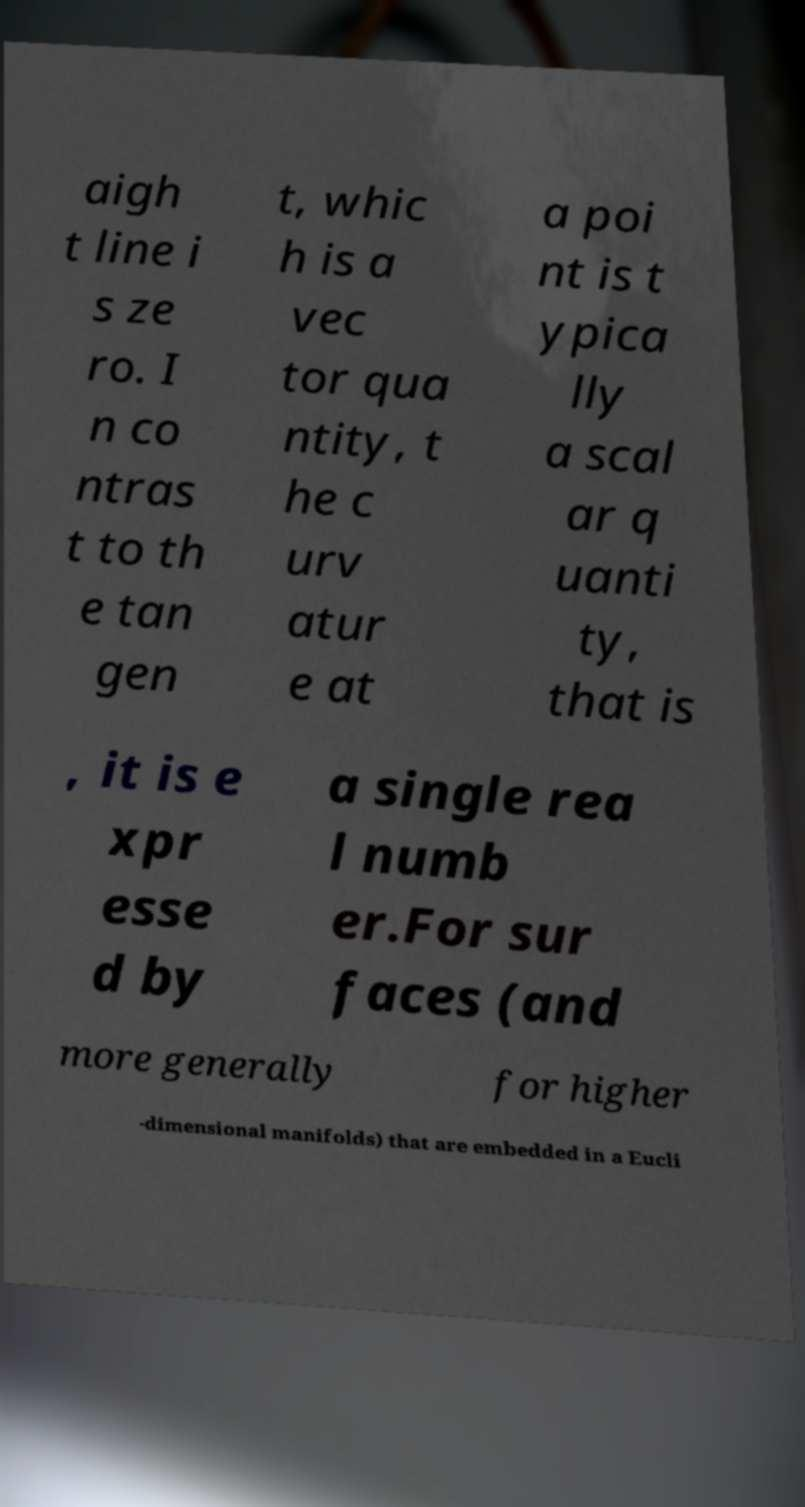Can you accurately transcribe the text from the provided image for me? aigh t line i s ze ro. I n co ntras t to th e tan gen t, whic h is a vec tor qua ntity, t he c urv atur e at a poi nt is t ypica lly a scal ar q uanti ty, that is , it is e xpr esse d by a single rea l numb er.For sur faces (and more generally for higher -dimensional manifolds) that are embedded in a Eucli 